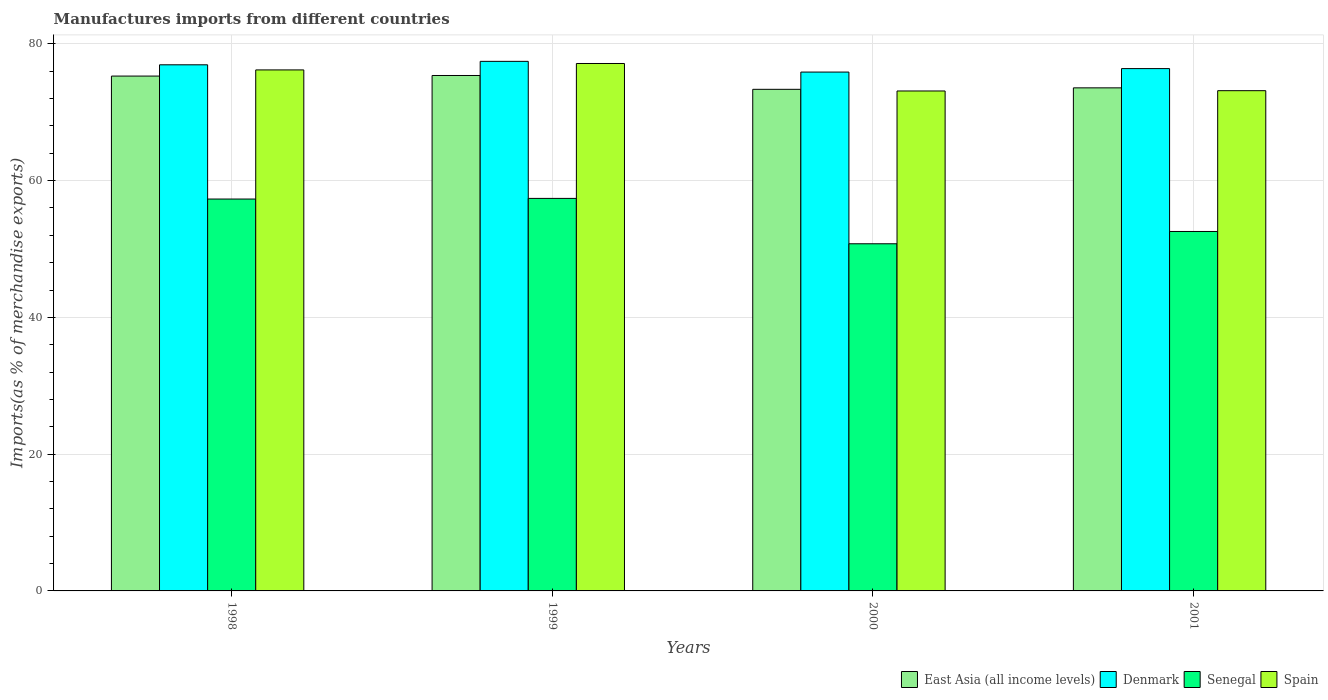Are the number of bars per tick equal to the number of legend labels?
Your answer should be very brief. Yes. Are the number of bars on each tick of the X-axis equal?
Your answer should be compact. Yes. How many bars are there on the 3rd tick from the right?
Your answer should be compact. 4. What is the percentage of imports to different countries in Spain in 2001?
Your answer should be very brief. 73.15. Across all years, what is the maximum percentage of imports to different countries in Spain?
Offer a terse response. 77.12. Across all years, what is the minimum percentage of imports to different countries in Denmark?
Offer a terse response. 75.87. In which year was the percentage of imports to different countries in Spain maximum?
Your answer should be very brief. 1999. In which year was the percentage of imports to different countries in Denmark minimum?
Provide a succinct answer. 2000. What is the total percentage of imports to different countries in Senegal in the graph?
Make the answer very short. 218.02. What is the difference between the percentage of imports to different countries in Spain in 1999 and that in 2001?
Your response must be concise. 3.97. What is the difference between the percentage of imports to different countries in East Asia (all income levels) in 1998 and the percentage of imports to different countries in Spain in 1999?
Offer a terse response. -1.84. What is the average percentage of imports to different countries in Spain per year?
Your answer should be compact. 74.89. In the year 2000, what is the difference between the percentage of imports to different countries in Denmark and percentage of imports to different countries in East Asia (all income levels)?
Offer a terse response. 2.52. What is the ratio of the percentage of imports to different countries in Denmark in 1999 to that in 2000?
Your response must be concise. 1.02. Is the percentage of imports to different countries in Senegal in 1999 less than that in 2001?
Your answer should be very brief. No. What is the difference between the highest and the second highest percentage of imports to different countries in Senegal?
Make the answer very short. 0.09. What is the difference between the highest and the lowest percentage of imports to different countries in Spain?
Keep it short and to the point. 4.02. Is the sum of the percentage of imports to different countries in East Asia (all income levels) in 1998 and 2000 greater than the maximum percentage of imports to different countries in Spain across all years?
Give a very brief answer. Yes. Is it the case that in every year, the sum of the percentage of imports to different countries in Spain and percentage of imports to different countries in East Asia (all income levels) is greater than the sum of percentage of imports to different countries in Denmark and percentage of imports to different countries in Senegal?
Make the answer very short. No. What does the 3rd bar from the left in 1999 represents?
Ensure brevity in your answer.  Senegal. What does the 4th bar from the right in 1998 represents?
Your answer should be compact. East Asia (all income levels). How many bars are there?
Provide a short and direct response. 16. Are all the bars in the graph horizontal?
Your answer should be very brief. No. How many years are there in the graph?
Give a very brief answer. 4. What is the difference between two consecutive major ticks on the Y-axis?
Give a very brief answer. 20. Does the graph contain any zero values?
Provide a short and direct response. No. Where does the legend appear in the graph?
Offer a terse response. Bottom right. What is the title of the graph?
Offer a very short reply. Manufactures imports from different countries. Does "Cabo Verde" appear as one of the legend labels in the graph?
Ensure brevity in your answer.  No. What is the label or title of the X-axis?
Offer a terse response. Years. What is the label or title of the Y-axis?
Your answer should be compact. Imports(as % of merchandise exports). What is the Imports(as % of merchandise exports) in East Asia (all income levels) in 1998?
Provide a succinct answer. 75.28. What is the Imports(as % of merchandise exports) of Denmark in 1998?
Keep it short and to the point. 76.93. What is the Imports(as % of merchandise exports) of Senegal in 1998?
Keep it short and to the point. 57.3. What is the Imports(as % of merchandise exports) in Spain in 1998?
Your answer should be compact. 76.18. What is the Imports(as % of merchandise exports) of East Asia (all income levels) in 1999?
Your answer should be compact. 75.37. What is the Imports(as % of merchandise exports) of Denmark in 1999?
Your answer should be very brief. 77.44. What is the Imports(as % of merchandise exports) of Senegal in 1999?
Make the answer very short. 57.4. What is the Imports(as % of merchandise exports) in Spain in 1999?
Give a very brief answer. 77.12. What is the Imports(as % of merchandise exports) of East Asia (all income levels) in 2000?
Provide a succinct answer. 73.35. What is the Imports(as % of merchandise exports) in Denmark in 2000?
Provide a short and direct response. 75.87. What is the Imports(as % of merchandise exports) of Senegal in 2000?
Your answer should be very brief. 50.76. What is the Imports(as % of merchandise exports) of Spain in 2000?
Offer a terse response. 73.1. What is the Imports(as % of merchandise exports) of East Asia (all income levels) in 2001?
Give a very brief answer. 73.56. What is the Imports(as % of merchandise exports) of Denmark in 2001?
Offer a very short reply. 76.38. What is the Imports(as % of merchandise exports) of Senegal in 2001?
Offer a terse response. 52.56. What is the Imports(as % of merchandise exports) of Spain in 2001?
Your answer should be compact. 73.15. Across all years, what is the maximum Imports(as % of merchandise exports) of East Asia (all income levels)?
Make the answer very short. 75.37. Across all years, what is the maximum Imports(as % of merchandise exports) of Denmark?
Your answer should be compact. 77.44. Across all years, what is the maximum Imports(as % of merchandise exports) in Senegal?
Your response must be concise. 57.4. Across all years, what is the maximum Imports(as % of merchandise exports) of Spain?
Your answer should be compact. 77.12. Across all years, what is the minimum Imports(as % of merchandise exports) in East Asia (all income levels)?
Your answer should be very brief. 73.35. Across all years, what is the minimum Imports(as % of merchandise exports) of Denmark?
Keep it short and to the point. 75.87. Across all years, what is the minimum Imports(as % of merchandise exports) of Senegal?
Your answer should be very brief. 50.76. Across all years, what is the minimum Imports(as % of merchandise exports) of Spain?
Your answer should be compact. 73.1. What is the total Imports(as % of merchandise exports) in East Asia (all income levels) in the graph?
Provide a succinct answer. 297.56. What is the total Imports(as % of merchandise exports) of Denmark in the graph?
Give a very brief answer. 306.61. What is the total Imports(as % of merchandise exports) in Senegal in the graph?
Your answer should be compact. 218.02. What is the total Imports(as % of merchandise exports) of Spain in the graph?
Provide a succinct answer. 299.56. What is the difference between the Imports(as % of merchandise exports) in East Asia (all income levels) in 1998 and that in 1999?
Provide a succinct answer. -0.08. What is the difference between the Imports(as % of merchandise exports) in Denmark in 1998 and that in 1999?
Offer a terse response. -0.51. What is the difference between the Imports(as % of merchandise exports) in Senegal in 1998 and that in 1999?
Make the answer very short. -0.09. What is the difference between the Imports(as % of merchandise exports) in Spain in 1998 and that in 1999?
Give a very brief answer. -0.94. What is the difference between the Imports(as % of merchandise exports) of East Asia (all income levels) in 1998 and that in 2000?
Your answer should be compact. 1.94. What is the difference between the Imports(as % of merchandise exports) of Denmark in 1998 and that in 2000?
Your answer should be compact. 1.06. What is the difference between the Imports(as % of merchandise exports) of Senegal in 1998 and that in 2000?
Make the answer very short. 6.54. What is the difference between the Imports(as % of merchandise exports) in Spain in 1998 and that in 2000?
Offer a very short reply. 3.08. What is the difference between the Imports(as % of merchandise exports) of East Asia (all income levels) in 1998 and that in 2001?
Ensure brevity in your answer.  1.72. What is the difference between the Imports(as % of merchandise exports) in Denmark in 1998 and that in 2001?
Provide a short and direct response. 0.56. What is the difference between the Imports(as % of merchandise exports) of Senegal in 1998 and that in 2001?
Your answer should be very brief. 4.74. What is the difference between the Imports(as % of merchandise exports) in Spain in 1998 and that in 2001?
Keep it short and to the point. 3.04. What is the difference between the Imports(as % of merchandise exports) of East Asia (all income levels) in 1999 and that in 2000?
Provide a succinct answer. 2.02. What is the difference between the Imports(as % of merchandise exports) in Denmark in 1999 and that in 2000?
Provide a short and direct response. 1.57. What is the difference between the Imports(as % of merchandise exports) of Senegal in 1999 and that in 2000?
Keep it short and to the point. 6.63. What is the difference between the Imports(as % of merchandise exports) in Spain in 1999 and that in 2000?
Offer a very short reply. 4.02. What is the difference between the Imports(as % of merchandise exports) in East Asia (all income levels) in 1999 and that in 2001?
Your answer should be compact. 1.81. What is the difference between the Imports(as % of merchandise exports) in Denmark in 1999 and that in 2001?
Give a very brief answer. 1.06. What is the difference between the Imports(as % of merchandise exports) of Senegal in 1999 and that in 2001?
Provide a succinct answer. 4.84. What is the difference between the Imports(as % of merchandise exports) of Spain in 1999 and that in 2001?
Your answer should be very brief. 3.97. What is the difference between the Imports(as % of merchandise exports) of East Asia (all income levels) in 2000 and that in 2001?
Offer a terse response. -0.21. What is the difference between the Imports(as % of merchandise exports) of Denmark in 2000 and that in 2001?
Provide a short and direct response. -0.51. What is the difference between the Imports(as % of merchandise exports) in Senegal in 2000 and that in 2001?
Your answer should be very brief. -1.8. What is the difference between the Imports(as % of merchandise exports) of Spain in 2000 and that in 2001?
Your response must be concise. -0.04. What is the difference between the Imports(as % of merchandise exports) in East Asia (all income levels) in 1998 and the Imports(as % of merchandise exports) in Denmark in 1999?
Offer a very short reply. -2.15. What is the difference between the Imports(as % of merchandise exports) in East Asia (all income levels) in 1998 and the Imports(as % of merchandise exports) in Senegal in 1999?
Give a very brief answer. 17.89. What is the difference between the Imports(as % of merchandise exports) in East Asia (all income levels) in 1998 and the Imports(as % of merchandise exports) in Spain in 1999?
Offer a very short reply. -1.84. What is the difference between the Imports(as % of merchandise exports) of Denmark in 1998 and the Imports(as % of merchandise exports) of Senegal in 1999?
Provide a short and direct response. 19.53. What is the difference between the Imports(as % of merchandise exports) of Denmark in 1998 and the Imports(as % of merchandise exports) of Spain in 1999?
Ensure brevity in your answer.  -0.19. What is the difference between the Imports(as % of merchandise exports) of Senegal in 1998 and the Imports(as % of merchandise exports) of Spain in 1999?
Provide a short and direct response. -19.82. What is the difference between the Imports(as % of merchandise exports) of East Asia (all income levels) in 1998 and the Imports(as % of merchandise exports) of Denmark in 2000?
Keep it short and to the point. -0.58. What is the difference between the Imports(as % of merchandise exports) in East Asia (all income levels) in 1998 and the Imports(as % of merchandise exports) in Senegal in 2000?
Offer a terse response. 24.52. What is the difference between the Imports(as % of merchandise exports) in East Asia (all income levels) in 1998 and the Imports(as % of merchandise exports) in Spain in 2000?
Keep it short and to the point. 2.18. What is the difference between the Imports(as % of merchandise exports) of Denmark in 1998 and the Imports(as % of merchandise exports) of Senegal in 2000?
Keep it short and to the point. 26.17. What is the difference between the Imports(as % of merchandise exports) in Denmark in 1998 and the Imports(as % of merchandise exports) in Spain in 2000?
Provide a succinct answer. 3.83. What is the difference between the Imports(as % of merchandise exports) in Senegal in 1998 and the Imports(as % of merchandise exports) in Spain in 2000?
Give a very brief answer. -15.8. What is the difference between the Imports(as % of merchandise exports) in East Asia (all income levels) in 1998 and the Imports(as % of merchandise exports) in Denmark in 2001?
Your answer should be compact. -1.09. What is the difference between the Imports(as % of merchandise exports) in East Asia (all income levels) in 1998 and the Imports(as % of merchandise exports) in Senegal in 2001?
Your answer should be compact. 22.72. What is the difference between the Imports(as % of merchandise exports) of East Asia (all income levels) in 1998 and the Imports(as % of merchandise exports) of Spain in 2001?
Offer a very short reply. 2.14. What is the difference between the Imports(as % of merchandise exports) of Denmark in 1998 and the Imports(as % of merchandise exports) of Senegal in 2001?
Offer a terse response. 24.37. What is the difference between the Imports(as % of merchandise exports) of Denmark in 1998 and the Imports(as % of merchandise exports) of Spain in 2001?
Give a very brief answer. 3.78. What is the difference between the Imports(as % of merchandise exports) in Senegal in 1998 and the Imports(as % of merchandise exports) in Spain in 2001?
Provide a short and direct response. -15.85. What is the difference between the Imports(as % of merchandise exports) of East Asia (all income levels) in 1999 and the Imports(as % of merchandise exports) of Denmark in 2000?
Your response must be concise. -0.5. What is the difference between the Imports(as % of merchandise exports) of East Asia (all income levels) in 1999 and the Imports(as % of merchandise exports) of Senegal in 2000?
Your answer should be very brief. 24.61. What is the difference between the Imports(as % of merchandise exports) of East Asia (all income levels) in 1999 and the Imports(as % of merchandise exports) of Spain in 2000?
Provide a succinct answer. 2.26. What is the difference between the Imports(as % of merchandise exports) of Denmark in 1999 and the Imports(as % of merchandise exports) of Senegal in 2000?
Give a very brief answer. 26.67. What is the difference between the Imports(as % of merchandise exports) in Denmark in 1999 and the Imports(as % of merchandise exports) in Spain in 2000?
Provide a succinct answer. 4.33. What is the difference between the Imports(as % of merchandise exports) of Senegal in 1999 and the Imports(as % of merchandise exports) of Spain in 2000?
Keep it short and to the point. -15.71. What is the difference between the Imports(as % of merchandise exports) in East Asia (all income levels) in 1999 and the Imports(as % of merchandise exports) in Denmark in 2001?
Keep it short and to the point. -1.01. What is the difference between the Imports(as % of merchandise exports) of East Asia (all income levels) in 1999 and the Imports(as % of merchandise exports) of Senegal in 2001?
Your response must be concise. 22.81. What is the difference between the Imports(as % of merchandise exports) in East Asia (all income levels) in 1999 and the Imports(as % of merchandise exports) in Spain in 2001?
Make the answer very short. 2.22. What is the difference between the Imports(as % of merchandise exports) of Denmark in 1999 and the Imports(as % of merchandise exports) of Senegal in 2001?
Your response must be concise. 24.88. What is the difference between the Imports(as % of merchandise exports) of Denmark in 1999 and the Imports(as % of merchandise exports) of Spain in 2001?
Offer a terse response. 4.29. What is the difference between the Imports(as % of merchandise exports) in Senegal in 1999 and the Imports(as % of merchandise exports) in Spain in 2001?
Give a very brief answer. -15.75. What is the difference between the Imports(as % of merchandise exports) in East Asia (all income levels) in 2000 and the Imports(as % of merchandise exports) in Denmark in 2001?
Keep it short and to the point. -3.03. What is the difference between the Imports(as % of merchandise exports) of East Asia (all income levels) in 2000 and the Imports(as % of merchandise exports) of Senegal in 2001?
Give a very brief answer. 20.79. What is the difference between the Imports(as % of merchandise exports) of East Asia (all income levels) in 2000 and the Imports(as % of merchandise exports) of Spain in 2001?
Offer a terse response. 0.2. What is the difference between the Imports(as % of merchandise exports) of Denmark in 2000 and the Imports(as % of merchandise exports) of Senegal in 2001?
Your answer should be compact. 23.31. What is the difference between the Imports(as % of merchandise exports) in Denmark in 2000 and the Imports(as % of merchandise exports) in Spain in 2001?
Offer a very short reply. 2.72. What is the difference between the Imports(as % of merchandise exports) in Senegal in 2000 and the Imports(as % of merchandise exports) in Spain in 2001?
Offer a very short reply. -22.39. What is the average Imports(as % of merchandise exports) in East Asia (all income levels) per year?
Keep it short and to the point. 74.39. What is the average Imports(as % of merchandise exports) in Denmark per year?
Offer a very short reply. 76.65. What is the average Imports(as % of merchandise exports) of Senegal per year?
Ensure brevity in your answer.  54.5. What is the average Imports(as % of merchandise exports) of Spain per year?
Provide a short and direct response. 74.89. In the year 1998, what is the difference between the Imports(as % of merchandise exports) of East Asia (all income levels) and Imports(as % of merchandise exports) of Denmark?
Keep it short and to the point. -1.65. In the year 1998, what is the difference between the Imports(as % of merchandise exports) in East Asia (all income levels) and Imports(as % of merchandise exports) in Senegal?
Keep it short and to the point. 17.98. In the year 1998, what is the difference between the Imports(as % of merchandise exports) of East Asia (all income levels) and Imports(as % of merchandise exports) of Spain?
Keep it short and to the point. -0.9. In the year 1998, what is the difference between the Imports(as % of merchandise exports) of Denmark and Imports(as % of merchandise exports) of Senegal?
Your response must be concise. 19.63. In the year 1998, what is the difference between the Imports(as % of merchandise exports) of Denmark and Imports(as % of merchandise exports) of Spain?
Make the answer very short. 0.75. In the year 1998, what is the difference between the Imports(as % of merchandise exports) in Senegal and Imports(as % of merchandise exports) in Spain?
Your answer should be compact. -18.88. In the year 1999, what is the difference between the Imports(as % of merchandise exports) in East Asia (all income levels) and Imports(as % of merchandise exports) in Denmark?
Your response must be concise. -2.07. In the year 1999, what is the difference between the Imports(as % of merchandise exports) of East Asia (all income levels) and Imports(as % of merchandise exports) of Senegal?
Make the answer very short. 17.97. In the year 1999, what is the difference between the Imports(as % of merchandise exports) of East Asia (all income levels) and Imports(as % of merchandise exports) of Spain?
Offer a very short reply. -1.75. In the year 1999, what is the difference between the Imports(as % of merchandise exports) of Denmark and Imports(as % of merchandise exports) of Senegal?
Make the answer very short. 20.04. In the year 1999, what is the difference between the Imports(as % of merchandise exports) in Denmark and Imports(as % of merchandise exports) in Spain?
Ensure brevity in your answer.  0.31. In the year 1999, what is the difference between the Imports(as % of merchandise exports) of Senegal and Imports(as % of merchandise exports) of Spain?
Give a very brief answer. -19.73. In the year 2000, what is the difference between the Imports(as % of merchandise exports) in East Asia (all income levels) and Imports(as % of merchandise exports) in Denmark?
Keep it short and to the point. -2.52. In the year 2000, what is the difference between the Imports(as % of merchandise exports) of East Asia (all income levels) and Imports(as % of merchandise exports) of Senegal?
Give a very brief answer. 22.59. In the year 2000, what is the difference between the Imports(as % of merchandise exports) of East Asia (all income levels) and Imports(as % of merchandise exports) of Spain?
Provide a succinct answer. 0.24. In the year 2000, what is the difference between the Imports(as % of merchandise exports) in Denmark and Imports(as % of merchandise exports) in Senegal?
Provide a short and direct response. 25.11. In the year 2000, what is the difference between the Imports(as % of merchandise exports) in Denmark and Imports(as % of merchandise exports) in Spain?
Your answer should be compact. 2.76. In the year 2000, what is the difference between the Imports(as % of merchandise exports) in Senegal and Imports(as % of merchandise exports) in Spain?
Ensure brevity in your answer.  -22.34. In the year 2001, what is the difference between the Imports(as % of merchandise exports) in East Asia (all income levels) and Imports(as % of merchandise exports) in Denmark?
Your response must be concise. -2.82. In the year 2001, what is the difference between the Imports(as % of merchandise exports) of East Asia (all income levels) and Imports(as % of merchandise exports) of Senegal?
Your answer should be very brief. 21. In the year 2001, what is the difference between the Imports(as % of merchandise exports) in East Asia (all income levels) and Imports(as % of merchandise exports) in Spain?
Ensure brevity in your answer.  0.41. In the year 2001, what is the difference between the Imports(as % of merchandise exports) in Denmark and Imports(as % of merchandise exports) in Senegal?
Offer a terse response. 23.82. In the year 2001, what is the difference between the Imports(as % of merchandise exports) of Denmark and Imports(as % of merchandise exports) of Spain?
Make the answer very short. 3.23. In the year 2001, what is the difference between the Imports(as % of merchandise exports) of Senegal and Imports(as % of merchandise exports) of Spain?
Provide a short and direct response. -20.59. What is the ratio of the Imports(as % of merchandise exports) in East Asia (all income levels) in 1998 to that in 1999?
Give a very brief answer. 1. What is the ratio of the Imports(as % of merchandise exports) of Denmark in 1998 to that in 1999?
Your answer should be compact. 0.99. What is the ratio of the Imports(as % of merchandise exports) in Spain in 1998 to that in 1999?
Make the answer very short. 0.99. What is the ratio of the Imports(as % of merchandise exports) in East Asia (all income levels) in 1998 to that in 2000?
Your answer should be very brief. 1.03. What is the ratio of the Imports(as % of merchandise exports) in Denmark in 1998 to that in 2000?
Your answer should be very brief. 1.01. What is the ratio of the Imports(as % of merchandise exports) in Senegal in 1998 to that in 2000?
Keep it short and to the point. 1.13. What is the ratio of the Imports(as % of merchandise exports) of Spain in 1998 to that in 2000?
Provide a succinct answer. 1.04. What is the ratio of the Imports(as % of merchandise exports) of East Asia (all income levels) in 1998 to that in 2001?
Provide a short and direct response. 1.02. What is the ratio of the Imports(as % of merchandise exports) of Denmark in 1998 to that in 2001?
Your response must be concise. 1.01. What is the ratio of the Imports(as % of merchandise exports) of Senegal in 1998 to that in 2001?
Ensure brevity in your answer.  1.09. What is the ratio of the Imports(as % of merchandise exports) in Spain in 1998 to that in 2001?
Offer a very short reply. 1.04. What is the ratio of the Imports(as % of merchandise exports) in East Asia (all income levels) in 1999 to that in 2000?
Provide a short and direct response. 1.03. What is the ratio of the Imports(as % of merchandise exports) of Denmark in 1999 to that in 2000?
Offer a very short reply. 1.02. What is the ratio of the Imports(as % of merchandise exports) in Senegal in 1999 to that in 2000?
Provide a short and direct response. 1.13. What is the ratio of the Imports(as % of merchandise exports) of Spain in 1999 to that in 2000?
Provide a short and direct response. 1.05. What is the ratio of the Imports(as % of merchandise exports) of East Asia (all income levels) in 1999 to that in 2001?
Your answer should be very brief. 1.02. What is the ratio of the Imports(as % of merchandise exports) in Denmark in 1999 to that in 2001?
Make the answer very short. 1.01. What is the ratio of the Imports(as % of merchandise exports) of Senegal in 1999 to that in 2001?
Give a very brief answer. 1.09. What is the ratio of the Imports(as % of merchandise exports) of Spain in 1999 to that in 2001?
Ensure brevity in your answer.  1.05. What is the ratio of the Imports(as % of merchandise exports) in Senegal in 2000 to that in 2001?
Give a very brief answer. 0.97. What is the ratio of the Imports(as % of merchandise exports) in Spain in 2000 to that in 2001?
Provide a succinct answer. 1. What is the difference between the highest and the second highest Imports(as % of merchandise exports) of East Asia (all income levels)?
Your response must be concise. 0.08. What is the difference between the highest and the second highest Imports(as % of merchandise exports) of Denmark?
Keep it short and to the point. 0.51. What is the difference between the highest and the second highest Imports(as % of merchandise exports) of Senegal?
Offer a terse response. 0.09. What is the difference between the highest and the second highest Imports(as % of merchandise exports) of Spain?
Your response must be concise. 0.94. What is the difference between the highest and the lowest Imports(as % of merchandise exports) in East Asia (all income levels)?
Give a very brief answer. 2.02. What is the difference between the highest and the lowest Imports(as % of merchandise exports) of Denmark?
Provide a succinct answer. 1.57. What is the difference between the highest and the lowest Imports(as % of merchandise exports) in Senegal?
Your answer should be compact. 6.63. What is the difference between the highest and the lowest Imports(as % of merchandise exports) in Spain?
Your answer should be compact. 4.02. 